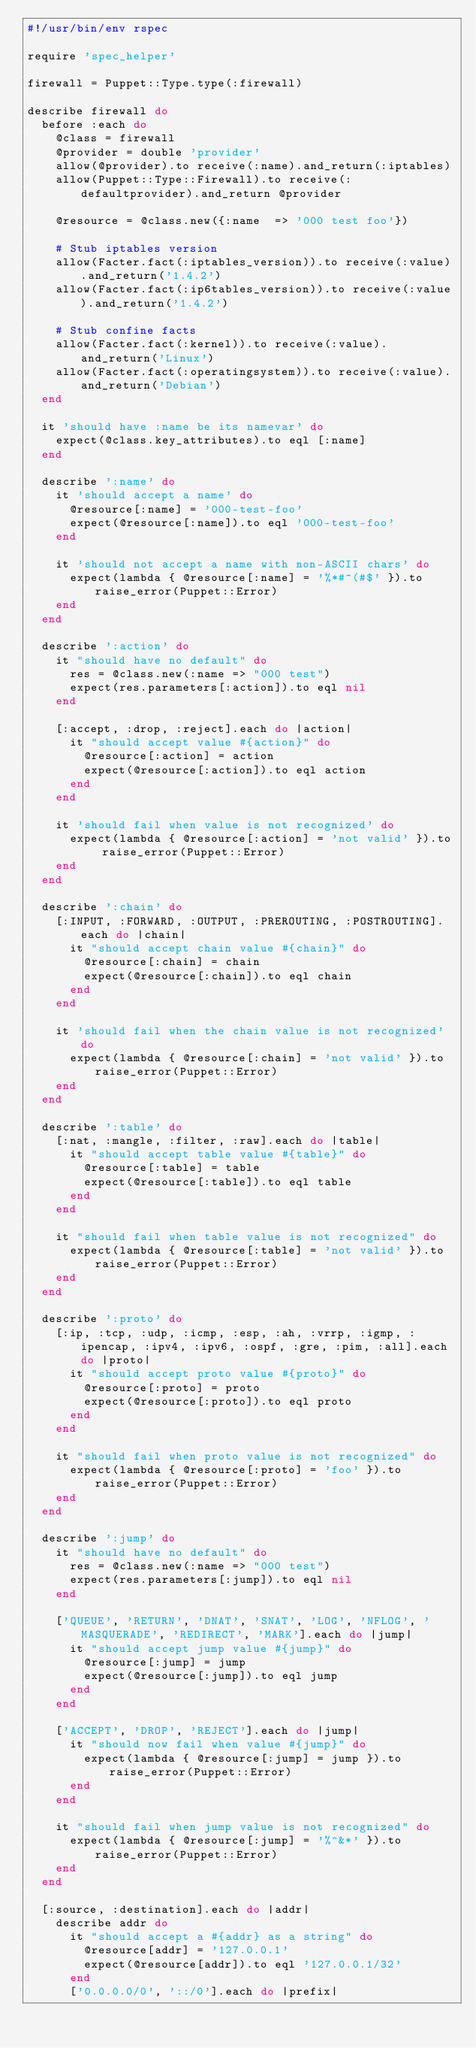Convert code to text. <code><loc_0><loc_0><loc_500><loc_500><_Ruby_>#!/usr/bin/env rspec

require 'spec_helper'

firewall = Puppet::Type.type(:firewall)

describe firewall do
  before :each do
    @class = firewall
    @provider = double 'provider'
    allow(@provider).to receive(:name).and_return(:iptables)
    allow(Puppet::Type::Firewall).to receive(:defaultprovider).and_return @provider

    @resource = @class.new({:name  => '000 test foo'})

    # Stub iptables version
    allow(Facter.fact(:iptables_version)).to receive(:value).and_return('1.4.2')
    allow(Facter.fact(:ip6tables_version)).to receive(:value).and_return('1.4.2')

    # Stub confine facts
    allow(Facter.fact(:kernel)).to receive(:value).and_return('Linux')
    allow(Facter.fact(:operatingsystem)).to receive(:value).and_return('Debian')
  end

  it 'should have :name be its namevar' do
    expect(@class.key_attributes).to eql [:name]
  end

  describe ':name' do
    it 'should accept a name' do
      @resource[:name] = '000-test-foo'
      expect(@resource[:name]).to eql '000-test-foo'
    end

    it 'should not accept a name with non-ASCII chars' do
      expect(lambda { @resource[:name] = '%*#^(#$' }).to raise_error(Puppet::Error)
    end
  end

  describe ':action' do
    it "should have no default" do
      res = @class.new(:name => "000 test")
      expect(res.parameters[:action]).to eql nil
    end

    [:accept, :drop, :reject].each do |action|
      it "should accept value #{action}" do
        @resource[:action] = action
        expect(@resource[:action]).to eql action
      end
    end

    it 'should fail when value is not recognized' do
      expect(lambda { @resource[:action] = 'not valid' }).to raise_error(Puppet::Error)
    end
  end

  describe ':chain' do
    [:INPUT, :FORWARD, :OUTPUT, :PREROUTING, :POSTROUTING].each do |chain|
      it "should accept chain value #{chain}" do
        @resource[:chain] = chain
        expect(@resource[:chain]).to eql chain
      end
    end

    it 'should fail when the chain value is not recognized' do
      expect(lambda { @resource[:chain] = 'not valid' }).to raise_error(Puppet::Error)
    end
  end

  describe ':table' do
    [:nat, :mangle, :filter, :raw].each do |table|
      it "should accept table value #{table}" do
        @resource[:table] = table
        expect(@resource[:table]).to eql table
      end
    end

    it "should fail when table value is not recognized" do
      expect(lambda { @resource[:table] = 'not valid' }).to raise_error(Puppet::Error)
    end
  end

  describe ':proto' do
    [:ip, :tcp, :udp, :icmp, :esp, :ah, :vrrp, :igmp, :ipencap, :ipv4, :ipv6, :ospf, :gre, :pim, :all].each do |proto|
      it "should accept proto value #{proto}" do
        @resource[:proto] = proto
        expect(@resource[:proto]).to eql proto
      end
    end

    it "should fail when proto value is not recognized" do
      expect(lambda { @resource[:proto] = 'foo' }).to raise_error(Puppet::Error)
    end
  end

  describe ':jump' do
    it "should have no default" do
      res = @class.new(:name => "000 test")
      expect(res.parameters[:jump]).to eql nil
    end

    ['QUEUE', 'RETURN', 'DNAT', 'SNAT', 'LOG', 'NFLOG', 'MASQUERADE', 'REDIRECT', 'MARK'].each do |jump|
      it "should accept jump value #{jump}" do
        @resource[:jump] = jump
        expect(@resource[:jump]).to eql jump
      end
    end

    ['ACCEPT', 'DROP', 'REJECT'].each do |jump|
      it "should now fail when value #{jump}" do
        expect(lambda { @resource[:jump] = jump }).to raise_error(Puppet::Error)
      end
    end

    it "should fail when jump value is not recognized" do
      expect(lambda { @resource[:jump] = '%^&*' }).to raise_error(Puppet::Error)
    end
  end

  [:source, :destination].each do |addr|
    describe addr do
      it "should accept a #{addr} as a string" do
        @resource[addr] = '127.0.0.1'
        expect(@resource[addr]).to eql '127.0.0.1/32'
      end
      ['0.0.0.0/0', '::/0'].each do |prefix|</code> 